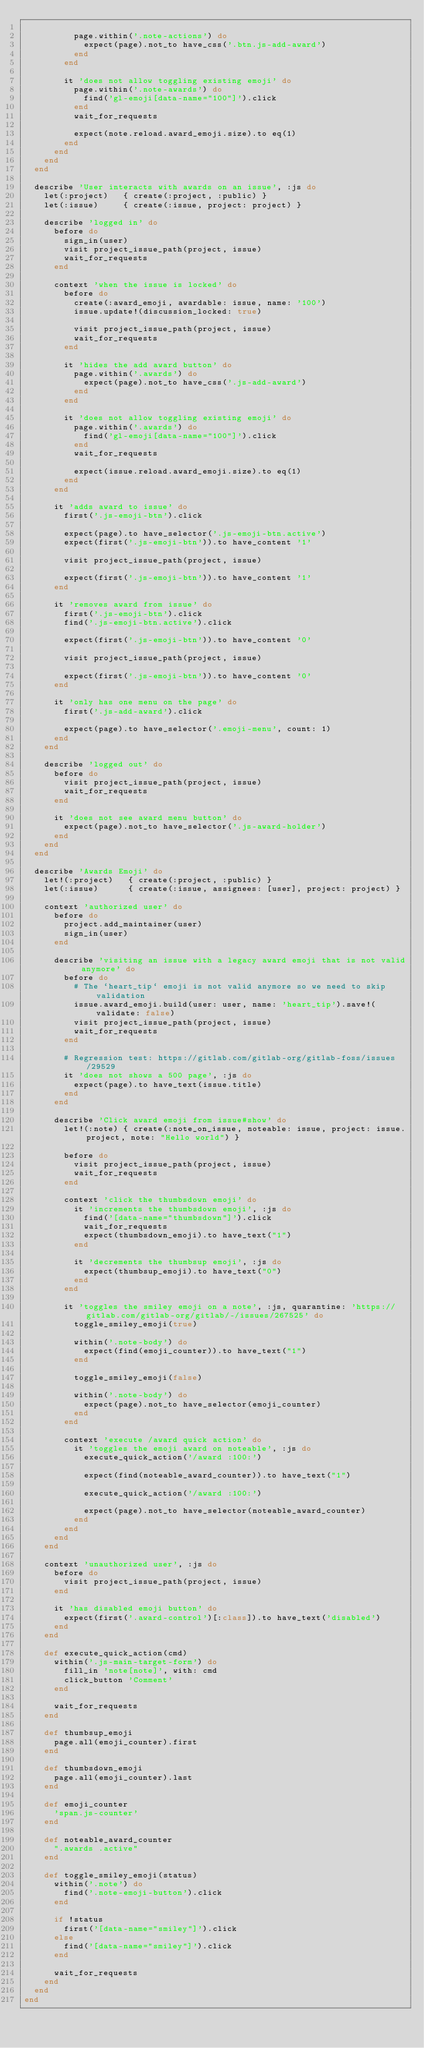Convert code to text. <code><loc_0><loc_0><loc_500><loc_500><_Ruby_>
          page.within('.note-actions') do
            expect(page).not_to have_css('.btn.js-add-award')
          end
        end

        it 'does not allow toggling existing emoji' do
          page.within('.note-awards') do
            find('gl-emoji[data-name="100"]').click
          end
          wait_for_requests

          expect(note.reload.award_emoji.size).to eq(1)
        end
      end
    end
  end

  describe 'User interacts with awards on an issue', :js do
    let(:project)   { create(:project, :public) }
    let(:issue)     { create(:issue, project: project) }

    describe 'logged in' do
      before do
        sign_in(user)
        visit project_issue_path(project, issue)
        wait_for_requests
      end

      context 'when the issue is locked' do
        before do
          create(:award_emoji, awardable: issue, name: '100')
          issue.update!(discussion_locked: true)

          visit project_issue_path(project, issue)
          wait_for_requests
        end

        it 'hides the add award button' do
          page.within('.awards') do
            expect(page).not_to have_css('.js-add-award')
          end
        end

        it 'does not allow toggling existing emoji' do
          page.within('.awards') do
            find('gl-emoji[data-name="100"]').click
          end
          wait_for_requests

          expect(issue.reload.award_emoji.size).to eq(1)
        end
      end

      it 'adds award to issue' do
        first('.js-emoji-btn').click

        expect(page).to have_selector('.js-emoji-btn.active')
        expect(first('.js-emoji-btn')).to have_content '1'

        visit project_issue_path(project, issue)

        expect(first('.js-emoji-btn')).to have_content '1'
      end

      it 'removes award from issue' do
        first('.js-emoji-btn').click
        find('.js-emoji-btn.active').click

        expect(first('.js-emoji-btn')).to have_content '0'

        visit project_issue_path(project, issue)

        expect(first('.js-emoji-btn')).to have_content '0'
      end

      it 'only has one menu on the page' do
        first('.js-add-award').click

        expect(page).to have_selector('.emoji-menu', count: 1)
      end
    end

    describe 'logged out' do
      before do
        visit project_issue_path(project, issue)
        wait_for_requests
      end

      it 'does not see award menu button' do
        expect(page).not_to have_selector('.js-award-holder')
      end
    end
  end

  describe 'Awards Emoji' do
    let!(:project)   { create(:project, :public) }
    let(:issue)      { create(:issue, assignees: [user], project: project) }

    context 'authorized user' do
      before do
        project.add_maintainer(user)
        sign_in(user)
      end

      describe 'visiting an issue with a legacy award emoji that is not valid anymore' do
        before do
          # The `heart_tip` emoji is not valid anymore so we need to skip validation
          issue.award_emoji.build(user: user, name: 'heart_tip').save!(validate: false)
          visit project_issue_path(project, issue)
          wait_for_requests
        end

        # Regression test: https://gitlab.com/gitlab-org/gitlab-foss/issues/29529
        it 'does not shows a 500 page', :js do
          expect(page).to have_text(issue.title)
        end
      end

      describe 'Click award emoji from issue#show' do
        let!(:note) { create(:note_on_issue, noteable: issue, project: issue.project, note: "Hello world") }

        before do
          visit project_issue_path(project, issue)
          wait_for_requests
        end

        context 'click the thumbsdown emoji' do
          it 'increments the thumbsdown emoji', :js do
            find('[data-name="thumbsdown"]').click
            wait_for_requests
            expect(thumbsdown_emoji).to have_text("1")
          end

          it 'decrements the thumbsup emoji', :js do
            expect(thumbsup_emoji).to have_text("0")
          end
        end

        it 'toggles the smiley emoji on a note', :js, quarantine: 'https://gitlab.com/gitlab-org/gitlab/-/issues/267525' do
          toggle_smiley_emoji(true)

          within('.note-body') do
            expect(find(emoji_counter)).to have_text("1")
          end

          toggle_smiley_emoji(false)

          within('.note-body') do
            expect(page).not_to have_selector(emoji_counter)
          end
        end

        context 'execute /award quick action' do
          it 'toggles the emoji award on noteable', :js do
            execute_quick_action('/award :100:')

            expect(find(noteable_award_counter)).to have_text("1")

            execute_quick_action('/award :100:')

            expect(page).not_to have_selector(noteable_award_counter)
          end
        end
      end
    end

    context 'unauthorized user', :js do
      before do
        visit project_issue_path(project, issue)
      end

      it 'has disabled emoji button' do
        expect(first('.award-control')[:class]).to have_text('disabled')
      end
    end

    def execute_quick_action(cmd)
      within('.js-main-target-form') do
        fill_in 'note[note]', with: cmd
        click_button 'Comment'
      end

      wait_for_requests
    end

    def thumbsup_emoji
      page.all(emoji_counter).first
    end

    def thumbsdown_emoji
      page.all(emoji_counter).last
    end

    def emoji_counter
      'span.js-counter'
    end

    def noteable_award_counter
      ".awards .active"
    end

    def toggle_smiley_emoji(status)
      within('.note') do
        find('.note-emoji-button').click
      end

      if !status
        first('[data-name="smiley"]').click
      else
        find('[data-name="smiley"]').click
      end

      wait_for_requests
    end
  end
end
</code> 